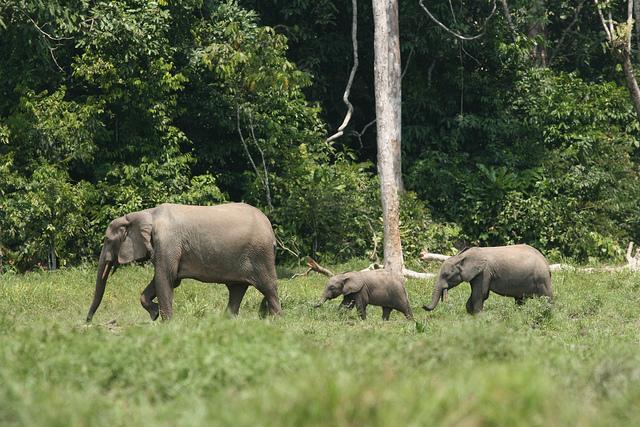Are there 3 elephants?
Concise answer only. Yes. Are all of the elephants full grown?
Short answer required. No. Are the elephants in the jungle?
Write a very short answer. Yes. 